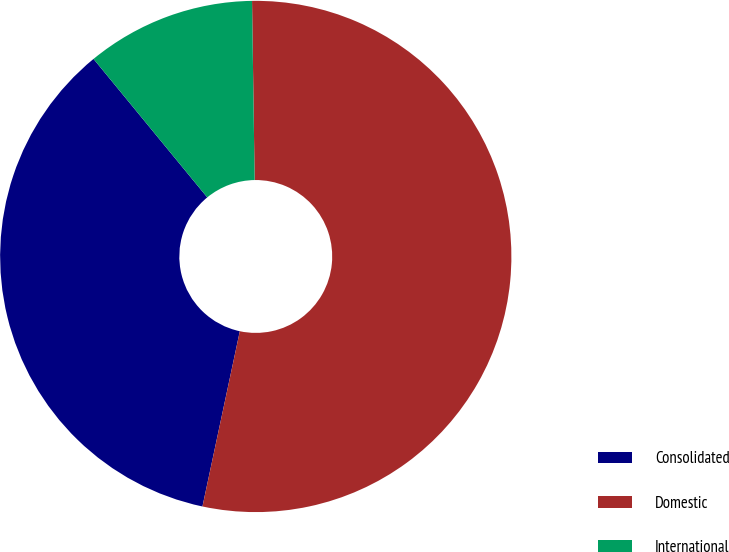Convert chart. <chart><loc_0><loc_0><loc_500><loc_500><pie_chart><fcel>Consolidated<fcel>Domestic<fcel>International<nl><fcel>35.71%<fcel>53.57%<fcel>10.71%<nl></chart> 